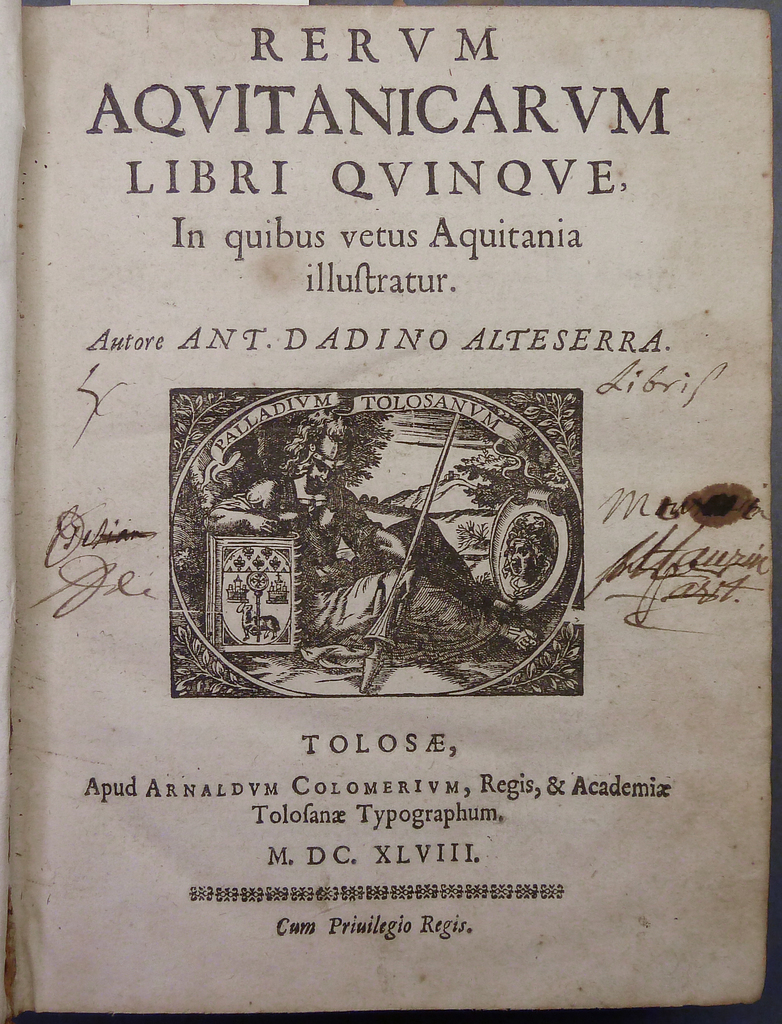Can you describe the artistic elements present on this title page and their possible symbolism? The title page features an elaborate emblem with classical figures, possibly representing muses or historical figures, which symbolize wisdom and guidance. The shield element might represent protection and strength, reflecting the proud historical narrative of Aquitaine. Such decoration would not only add aesthetic value but also signify the cultural and intellectual richness of the material within. 